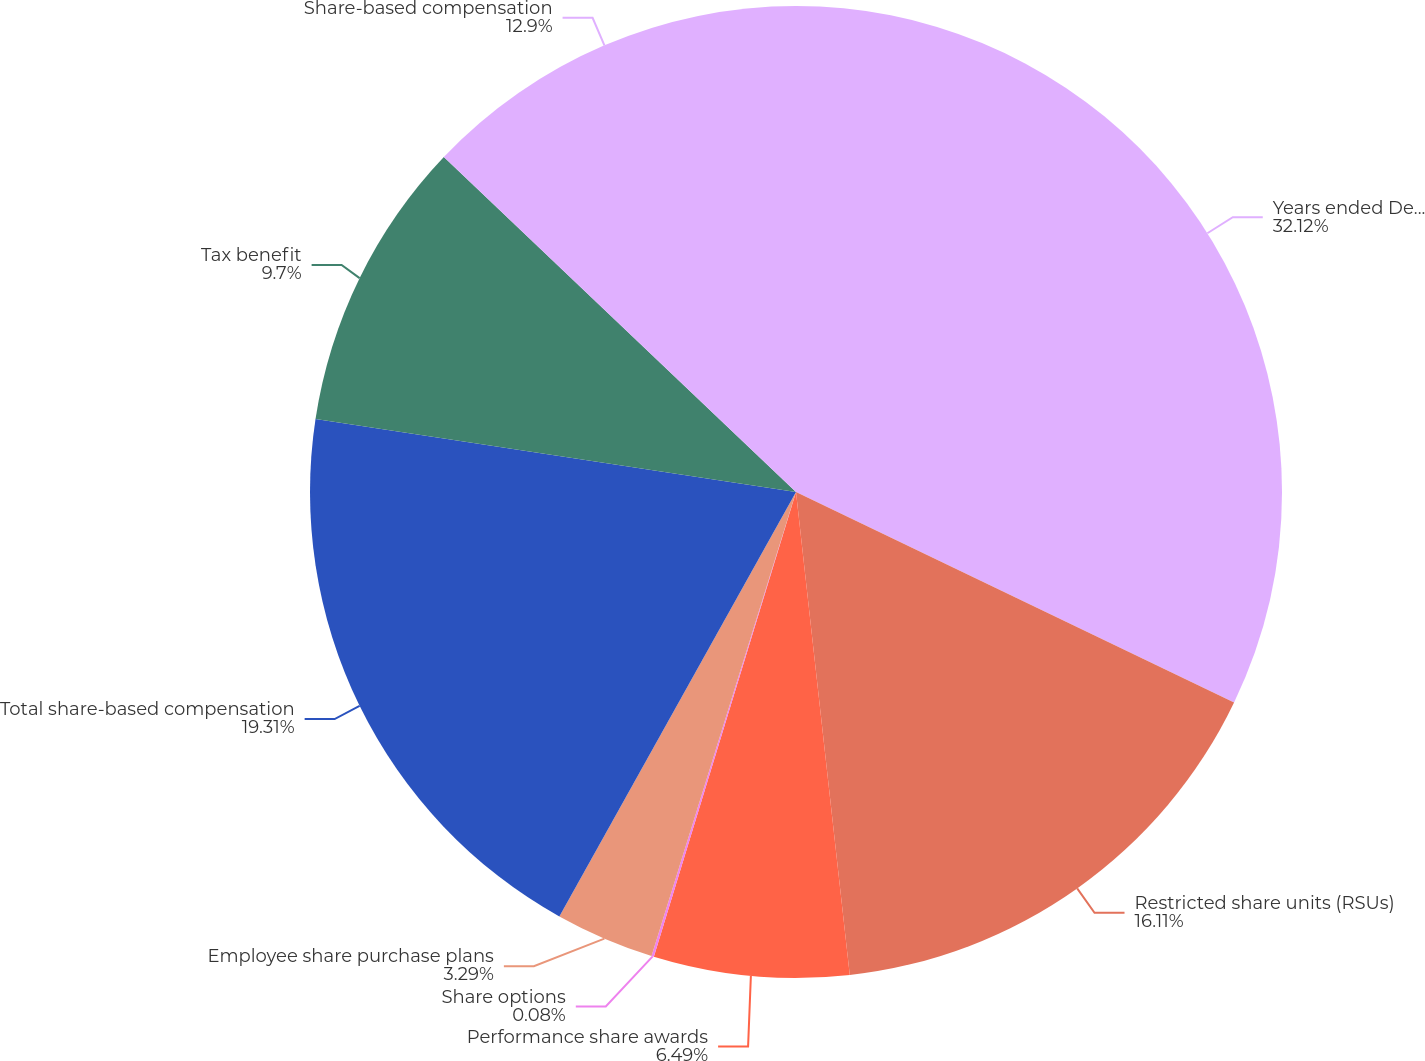Convert chart to OTSL. <chart><loc_0><loc_0><loc_500><loc_500><pie_chart><fcel>Years ended December 31<fcel>Restricted share units (RSUs)<fcel>Performance share awards<fcel>Share options<fcel>Employee share purchase plans<fcel>Total share-based compensation<fcel>Tax benefit<fcel>Share-based compensation<nl><fcel>32.13%<fcel>16.11%<fcel>6.49%<fcel>0.08%<fcel>3.29%<fcel>19.31%<fcel>9.7%<fcel>12.9%<nl></chart> 